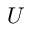<formula> <loc_0><loc_0><loc_500><loc_500>U</formula> 